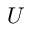<formula> <loc_0><loc_0><loc_500><loc_500>U</formula> 